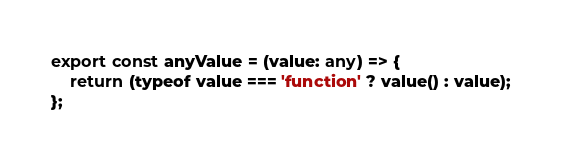Convert code to text. <code><loc_0><loc_0><loc_500><loc_500><_TypeScript_>export const anyValue = (value: any) => {
	return (typeof value === 'function' ? value() : value);
};
</code> 